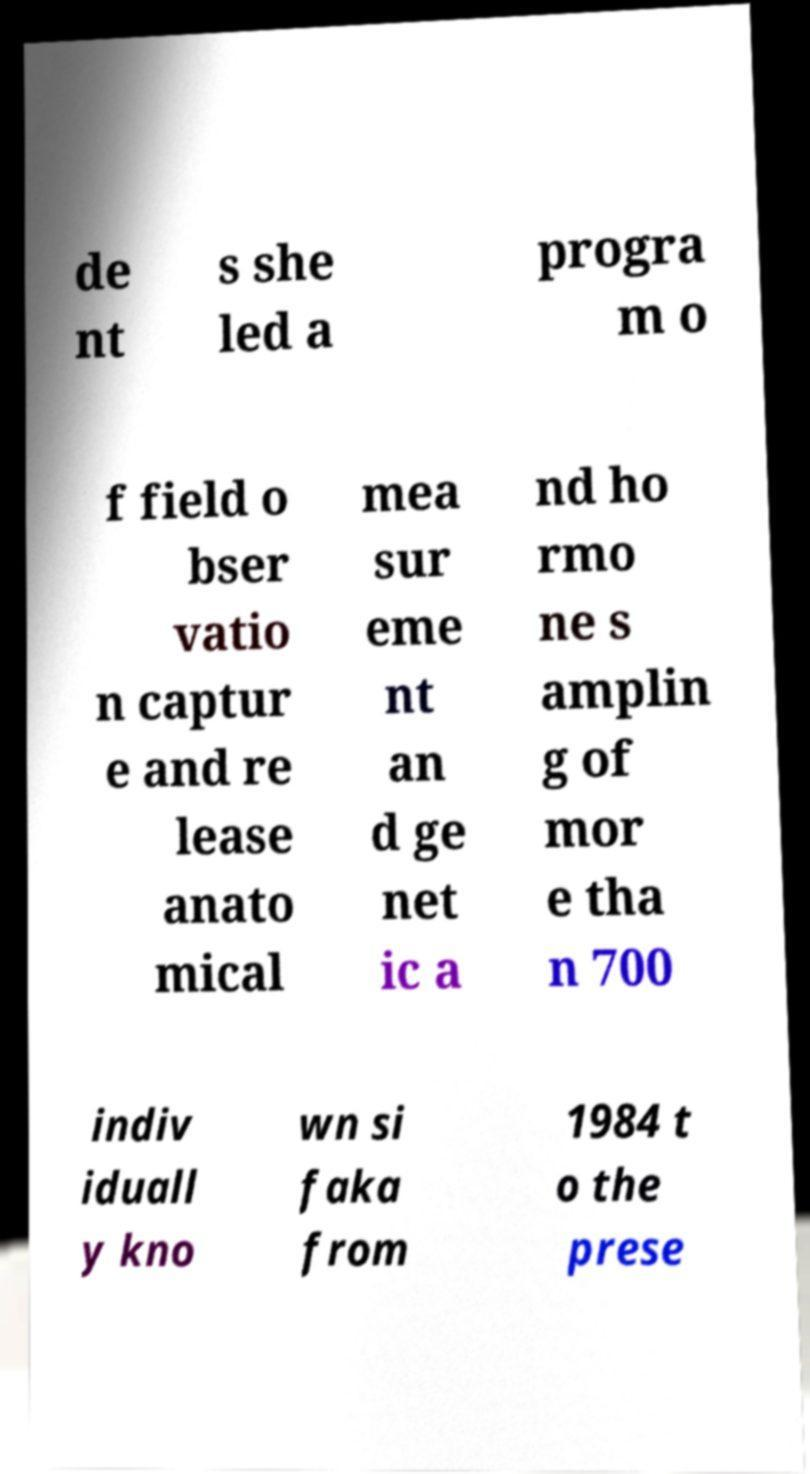I need the written content from this picture converted into text. Can you do that? de nt s she led a progra m o f field o bser vatio n captur e and re lease anato mical mea sur eme nt an d ge net ic a nd ho rmo ne s amplin g of mor e tha n 700 indiv iduall y kno wn si faka from 1984 t o the prese 